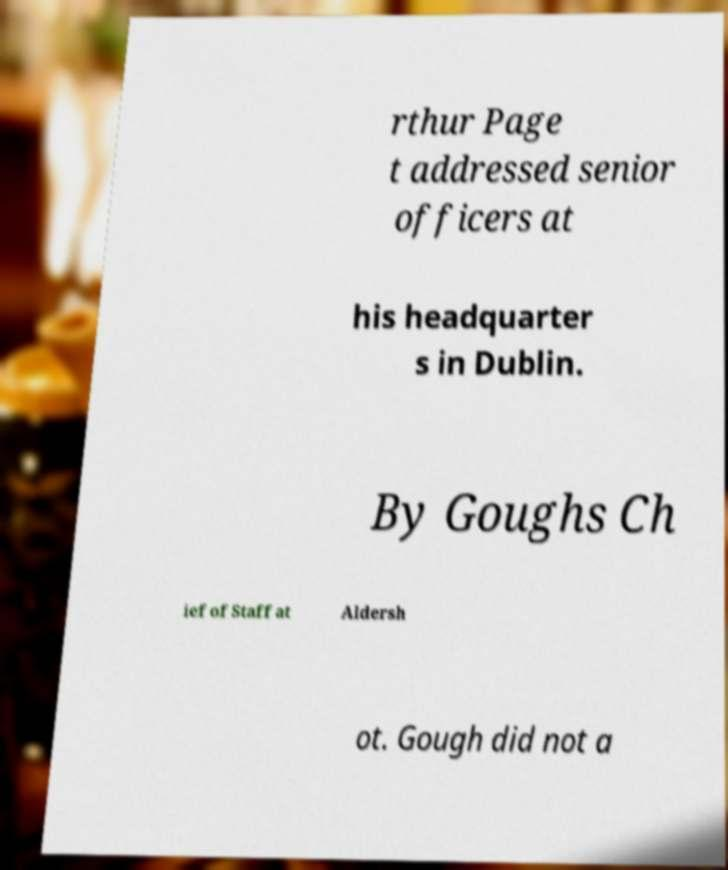Please read and relay the text visible in this image. What does it say? rthur Page t addressed senior officers at his headquarter s in Dublin. By Goughs Ch ief of Staff at Aldersh ot. Gough did not a 